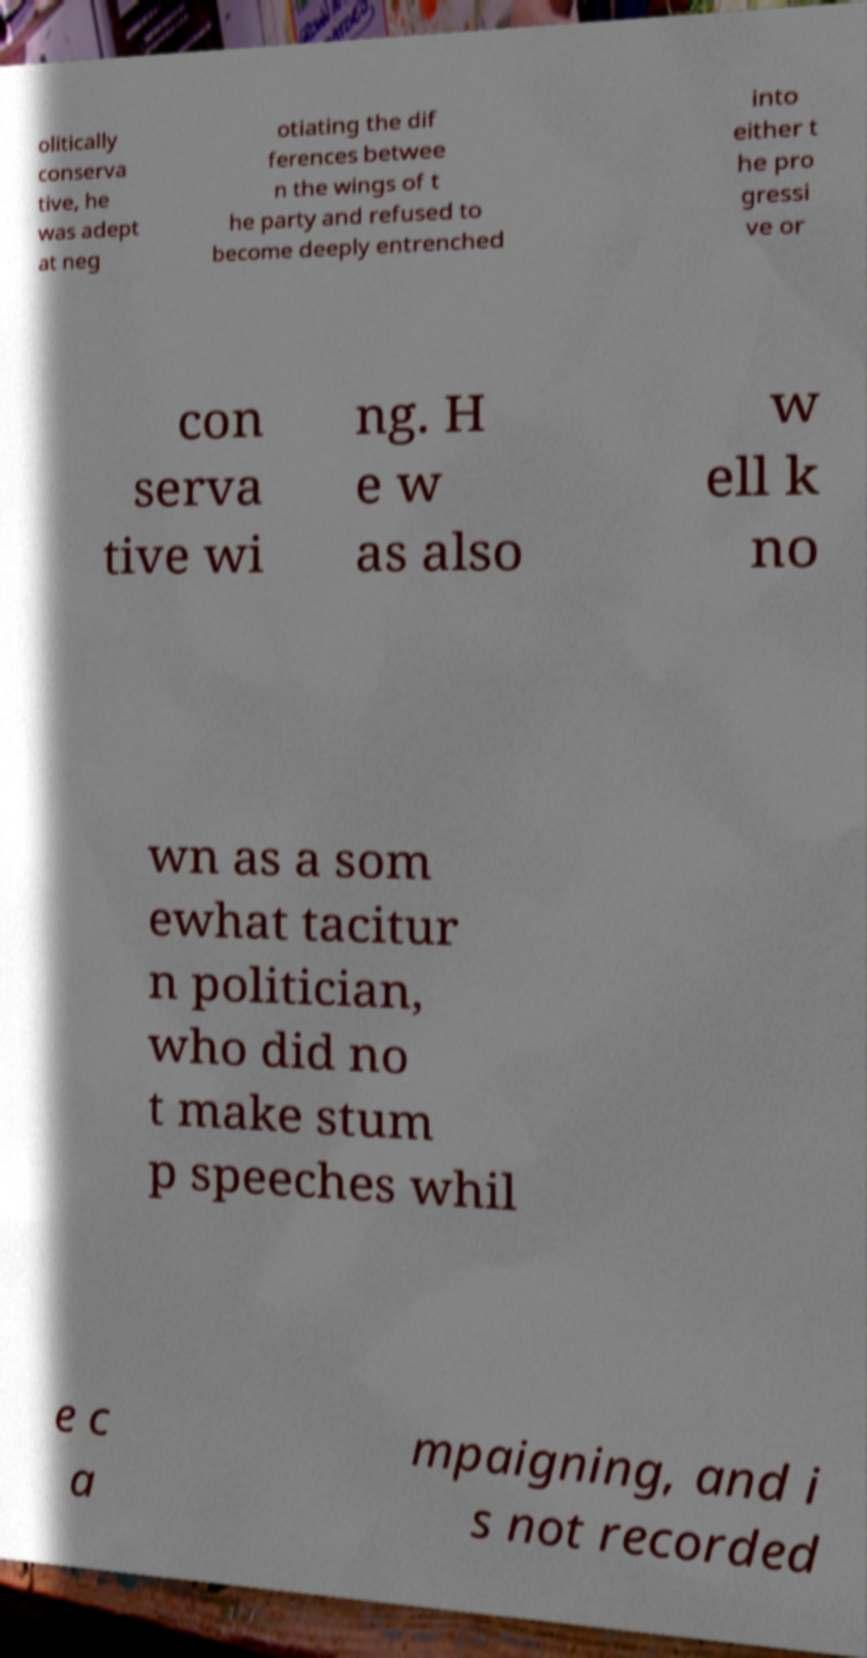There's text embedded in this image that I need extracted. Can you transcribe it verbatim? olitically conserva tive, he was adept at neg otiating the dif ferences betwee n the wings of t he party and refused to become deeply entrenched into either t he pro gressi ve or con serva tive wi ng. H e w as also w ell k no wn as a som ewhat tacitur n politician, who did no t make stum p speeches whil e c a mpaigning, and i s not recorded 